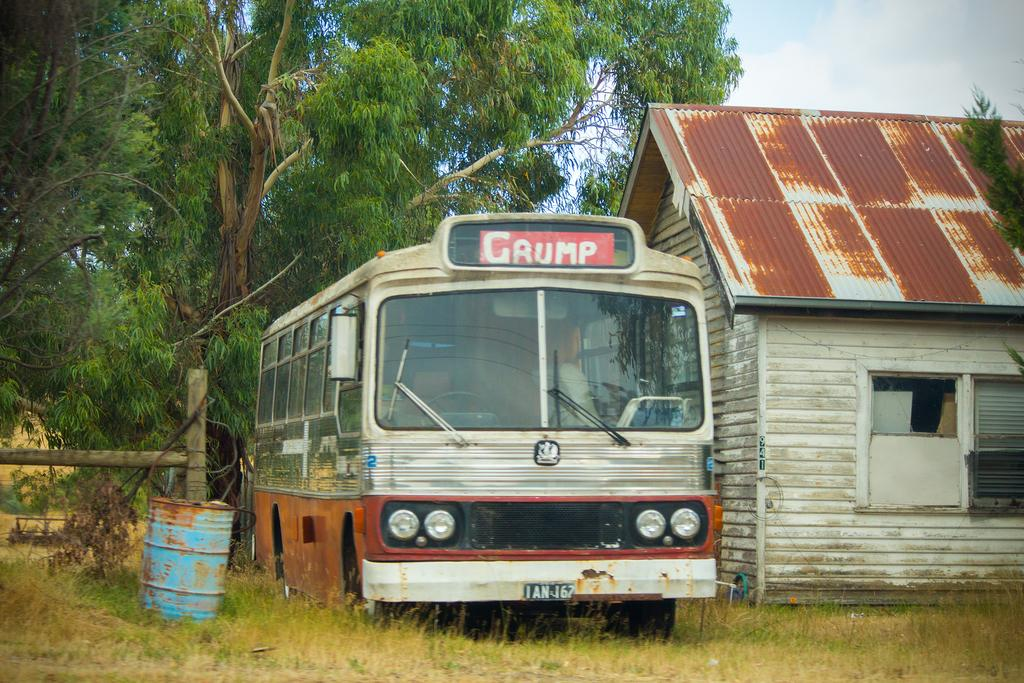Provide a one-sentence caption for the provided image. An old bus with a sign on the top that says "Grump" next to a shed with a metal roof. 